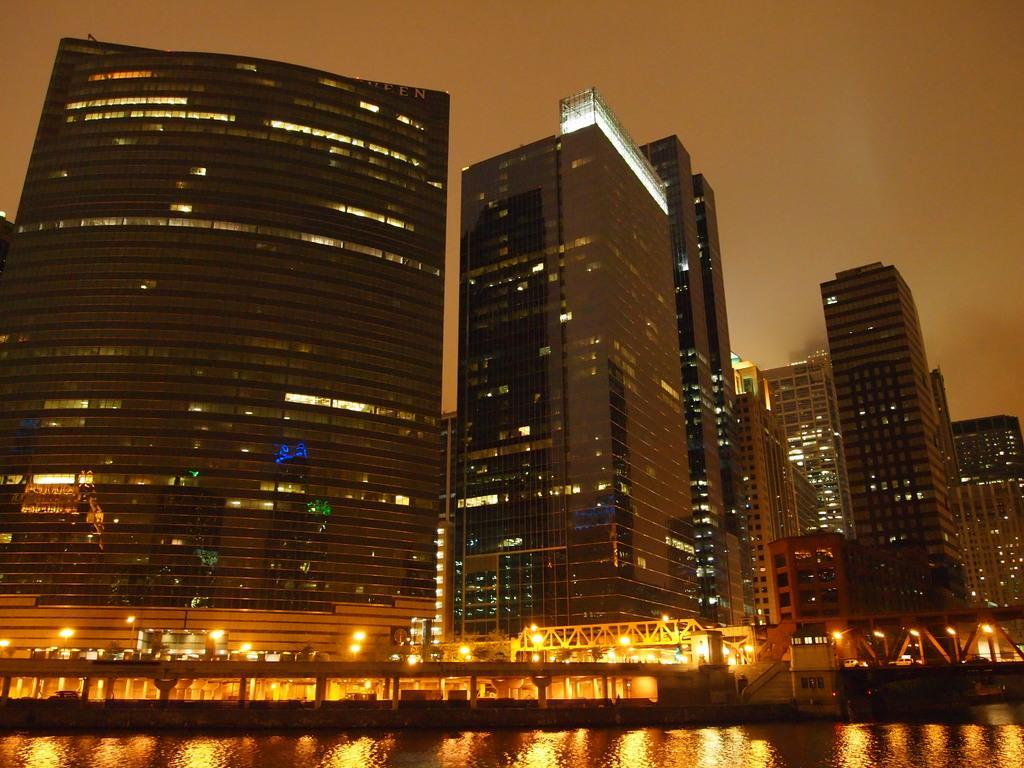In one or two sentences, can you explain what this image depicts? This picture is clicked outside. In the foreground we can see a water body, lights, metal rods and the stairs and some other items. In the background we can see the sky, buildings and skyscrapers and some other items. 